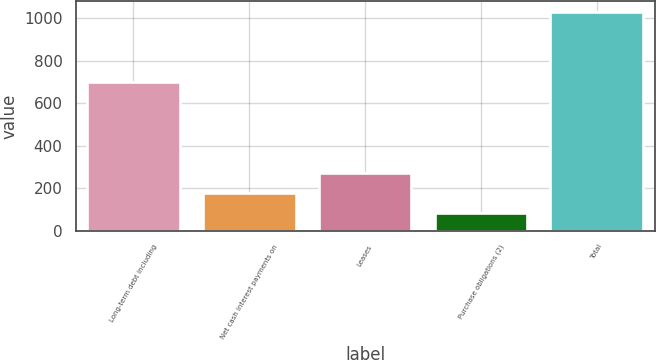Convert chart to OTSL. <chart><loc_0><loc_0><loc_500><loc_500><bar_chart><fcel>Long-term debt including<fcel>Net cash interest payments on<fcel>Leases<fcel>Purchase obligations (2)<fcel>Total<nl><fcel>698<fcel>177.5<fcel>272<fcel>83<fcel>1028<nl></chart> 